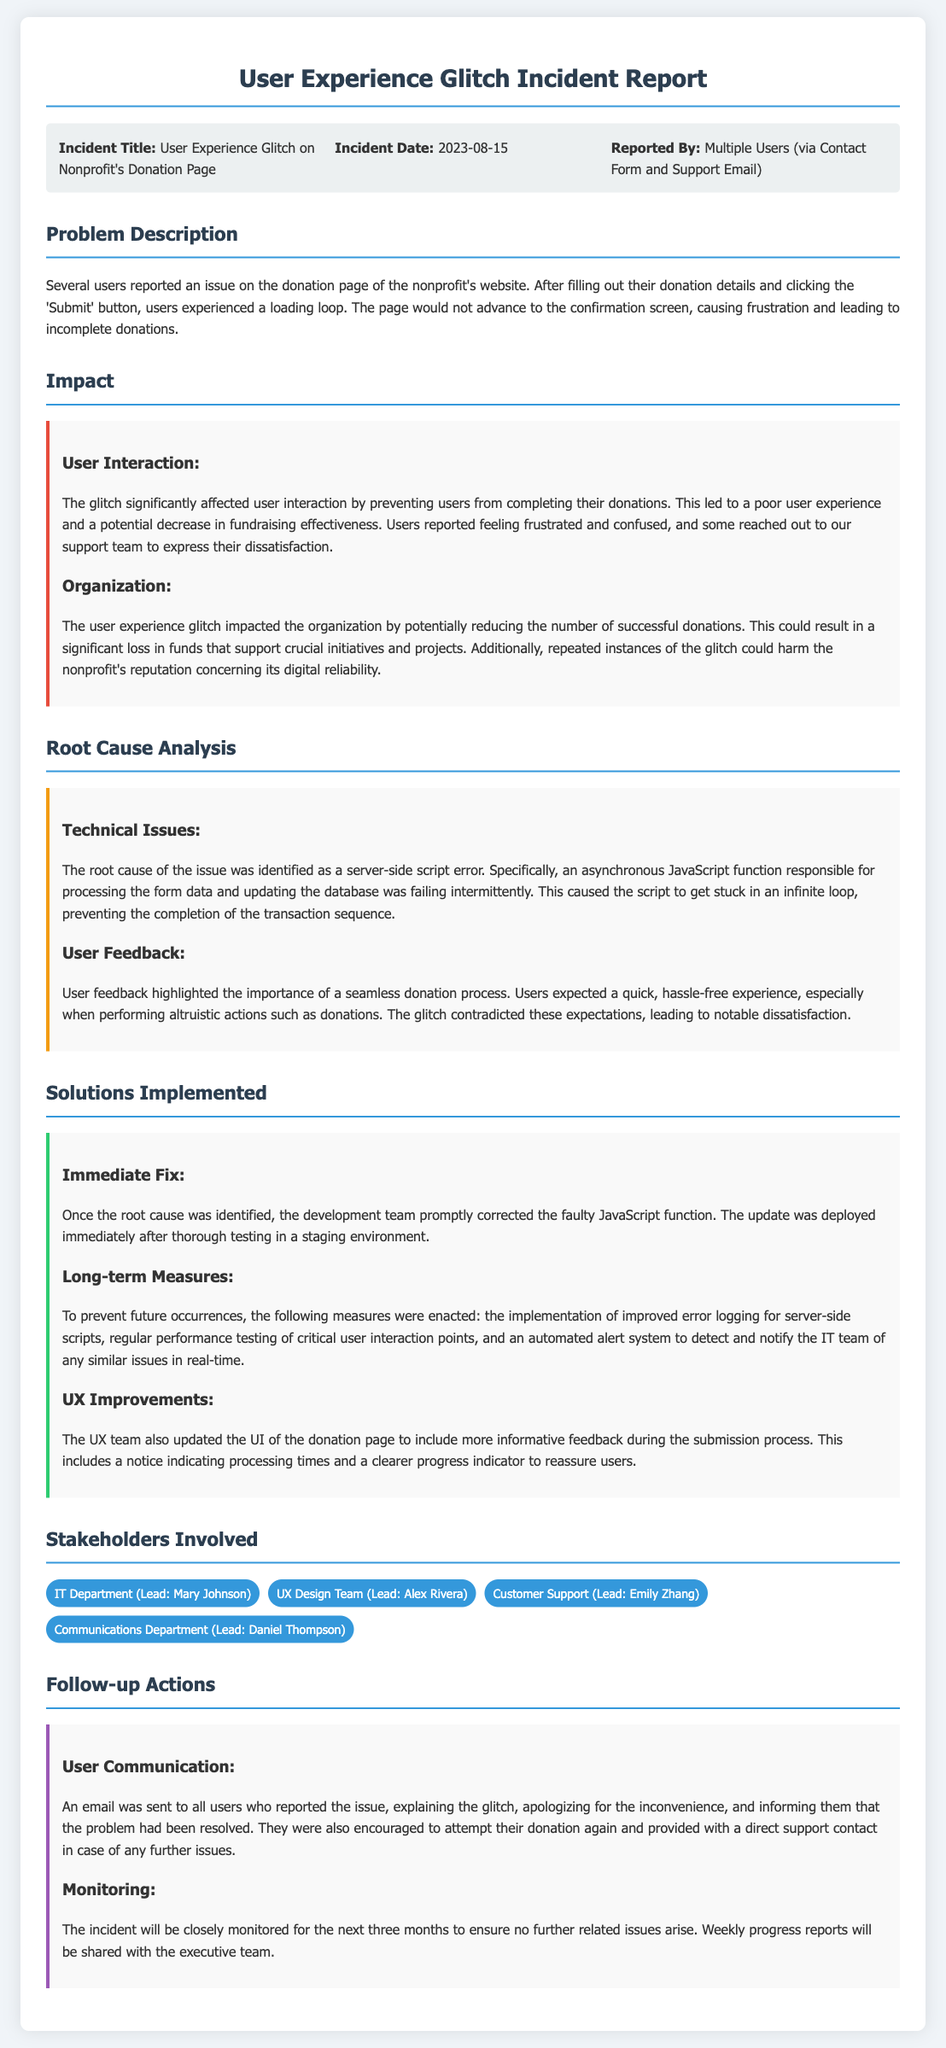what is the incident title? The incident title is stated in the header section of the document.
Answer: User Experience Glitch on Nonprofit's Donation Page when was the incident reported? The incident date is listed in the header section of the document.
Answer: 2023-08-15 who reported the issue? The document specifies that multiple users reported the issue.
Answer: Multiple Users (via Contact Form and Support Email) what was the root cause of the issue? The root cause is described in the root cause analysis section of the document.
Answer: Server-side script error what are the immediate solutions implemented? The immediate fix is detailed under the solutions implemented section.
Answer: The faulty JavaScript function was corrected how will the organization monitor the incident? Monitoring actions are described in the follow-up actions section of the document.
Answer: Closely monitored for the next three months how did the glitch impact users? The impact on user interaction is highlighted in the impact section of the document.
Answer: Preventing users from completing their donations what improvements were made to the user experience? UX improvements are mentioned in the solutions implemented section of the document.
Answer: Updated the UI of the donation page which department led the User Experience improvements? The stakeholders section identifies the lead of the UX Design Team.
Answer: Alex Rivera 